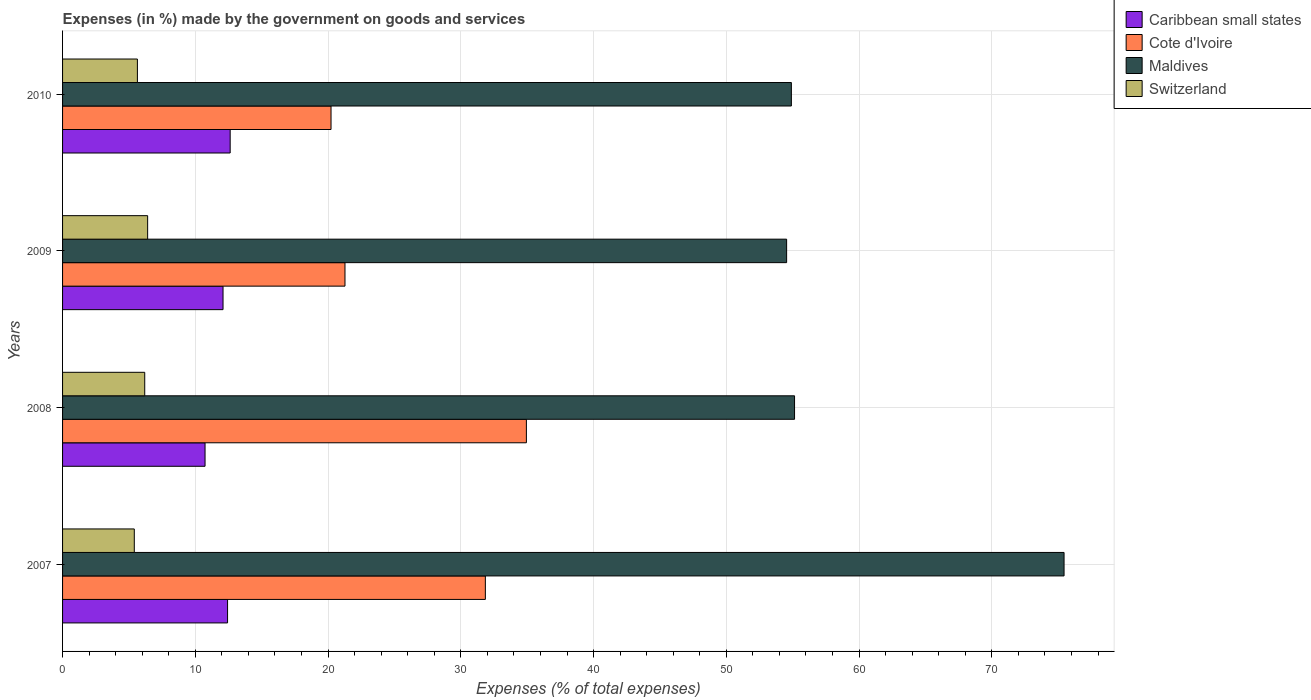How many different coloured bars are there?
Make the answer very short. 4. How many groups of bars are there?
Your answer should be compact. 4. How many bars are there on the 2nd tick from the bottom?
Ensure brevity in your answer.  4. What is the label of the 3rd group of bars from the top?
Give a very brief answer. 2008. In how many cases, is the number of bars for a given year not equal to the number of legend labels?
Your answer should be very brief. 0. What is the percentage of expenses made by the government on goods and services in Maldives in 2010?
Your answer should be very brief. 54.9. Across all years, what is the maximum percentage of expenses made by the government on goods and services in Cote d'Ivoire?
Give a very brief answer. 34.94. Across all years, what is the minimum percentage of expenses made by the government on goods and services in Caribbean small states?
Give a very brief answer. 10.73. In which year was the percentage of expenses made by the government on goods and services in Maldives minimum?
Make the answer very short. 2009. What is the total percentage of expenses made by the government on goods and services in Maldives in the graph?
Make the answer very short. 240.02. What is the difference between the percentage of expenses made by the government on goods and services in Maldives in 2008 and that in 2010?
Keep it short and to the point. 0.24. What is the difference between the percentage of expenses made by the government on goods and services in Cote d'Ivoire in 2009 and the percentage of expenses made by the government on goods and services in Caribbean small states in 2007?
Provide a short and direct response. 8.85. What is the average percentage of expenses made by the government on goods and services in Cote d'Ivoire per year?
Your answer should be very brief. 27.07. In the year 2009, what is the difference between the percentage of expenses made by the government on goods and services in Switzerland and percentage of expenses made by the government on goods and services in Caribbean small states?
Ensure brevity in your answer.  -5.68. In how many years, is the percentage of expenses made by the government on goods and services in Maldives greater than 8 %?
Offer a very short reply. 4. What is the ratio of the percentage of expenses made by the government on goods and services in Maldives in 2007 to that in 2009?
Provide a short and direct response. 1.38. Is the percentage of expenses made by the government on goods and services in Switzerland in 2009 less than that in 2010?
Your response must be concise. No. What is the difference between the highest and the second highest percentage of expenses made by the government on goods and services in Caribbean small states?
Keep it short and to the point. 0.2. What is the difference between the highest and the lowest percentage of expenses made by the government on goods and services in Switzerland?
Provide a short and direct response. 1. In how many years, is the percentage of expenses made by the government on goods and services in Cote d'Ivoire greater than the average percentage of expenses made by the government on goods and services in Cote d'Ivoire taken over all years?
Ensure brevity in your answer.  2. Is the sum of the percentage of expenses made by the government on goods and services in Switzerland in 2007 and 2008 greater than the maximum percentage of expenses made by the government on goods and services in Cote d'Ivoire across all years?
Ensure brevity in your answer.  No. What does the 4th bar from the top in 2010 represents?
Ensure brevity in your answer.  Caribbean small states. What does the 4th bar from the bottom in 2009 represents?
Ensure brevity in your answer.  Switzerland. Is it the case that in every year, the sum of the percentage of expenses made by the government on goods and services in Maldives and percentage of expenses made by the government on goods and services in Switzerland is greater than the percentage of expenses made by the government on goods and services in Caribbean small states?
Provide a succinct answer. Yes. How many bars are there?
Give a very brief answer. 16. Are all the bars in the graph horizontal?
Your answer should be very brief. Yes. Does the graph contain grids?
Offer a terse response. Yes. Where does the legend appear in the graph?
Your answer should be compact. Top right. How many legend labels are there?
Ensure brevity in your answer.  4. How are the legend labels stacked?
Offer a terse response. Vertical. What is the title of the graph?
Your response must be concise. Expenses (in %) made by the government on goods and services. What is the label or title of the X-axis?
Your answer should be compact. Expenses (% of total expenses). What is the Expenses (% of total expenses) of Caribbean small states in 2007?
Your answer should be compact. 12.43. What is the Expenses (% of total expenses) of Cote d'Ivoire in 2007?
Your answer should be very brief. 31.85. What is the Expenses (% of total expenses) of Maldives in 2007?
Your answer should be compact. 75.44. What is the Expenses (% of total expenses) in Switzerland in 2007?
Keep it short and to the point. 5.4. What is the Expenses (% of total expenses) in Caribbean small states in 2008?
Make the answer very short. 10.73. What is the Expenses (% of total expenses) of Cote d'Ivoire in 2008?
Your answer should be very brief. 34.94. What is the Expenses (% of total expenses) in Maldives in 2008?
Offer a terse response. 55.14. What is the Expenses (% of total expenses) of Switzerland in 2008?
Your response must be concise. 6.19. What is the Expenses (% of total expenses) in Caribbean small states in 2009?
Provide a succinct answer. 12.09. What is the Expenses (% of total expenses) of Cote d'Ivoire in 2009?
Make the answer very short. 21.27. What is the Expenses (% of total expenses) of Maldives in 2009?
Provide a short and direct response. 54.54. What is the Expenses (% of total expenses) in Switzerland in 2009?
Your response must be concise. 6.41. What is the Expenses (% of total expenses) of Caribbean small states in 2010?
Ensure brevity in your answer.  12.63. What is the Expenses (% of total expenses) of Cote d'Ivoire in 2010?
Offer a terse response. 20.22. What is the Expenses (% of total expenses) of Maldives in 2010?
Give a very brief answer. 54.9. What is the Expenses (% of total expenses) in Switzerland in 2010?
Make the answer very short. 5.64. Across all years, what is the maximum Expenses (% of total expenses) of Caribbean small states?
Make the answer very short. 12.63. Across all years, what is the maximum Expenses (% of total expenses) of Cote d'Ivoire?
Keep it short and to the point. 34.94. Across all years, what is the maximum Expenses (% of total expenses) of Maldives?
Your response must be concise. 75.44. Across all years, what is the maximum Expenses (% of total expenses) of Switzerland?
Keep it short and to the point. 6.41. Across all years, what is the minimum Expenses (% of total expenses) of Caribbean small states?
Offer a terse response. 10.73. Across all years, what is the minimum Expenses (% of total expenses) in Cote d'Ivoire?
Ensure brevity in your answer.  20.22. Across all years, what is the minimum Expenses (% of total expenses) in Maldives?
Your response must be concise. 54.54. Across all years, what is the minimum Expenses (% of total expenses) in Switzerland?
Ensure brevity in your answer.  5.4. What is the total Expenses (% of total expenses) in Caribbean small states in the graph?
Provide a succinct answer. 47.88. What is the total Expenses (% of total expenses) in Cote d'Ivoire in the graph?
Your answer should be very brief. 108.28. What is the total Expenses (% of total expenses) in Maldives in the graph?
Your answer should be compact. 240.02. What is the total Expenses (% of total expenses) of Switzerland in the graph?
Offer a very short reply. 23.64. What is the difference between the Expenses (% of total expenses) of Caribbean small states in 2007 and that in 2008?
Keep it short and to the point. 1.7. What is the difference between the Expenses (% of total expenses) in Cote d'Ivoire in 2007 and that in 2008?
Provide a short and direct response. -3.09. What is the difference between the Expenses (% of total expenses) in Maldives in 2007 and that in 2008?
Your answer should be very brief. 20.3. What is the difference between the Expenses (% of total expenses) of Switzerland in 2007 and that in 2008?
Provide a short and direct response. -0.79. What is the difference between the Expenses (% of total expenses) in Caribbean small states in 2007 and that in 2009?
Make the answer very short. 0.34. What is the difference between the Expenses (% of total expenses) in Cote d'Ivoire in 2007 and that in 2009?
Keep it short and to the point. 10.57. What is the difference between the Expenses (% of total expenses) in Maldives in 2007 and that in 2009?
Offer a terse response. 20.9. What is the difference between the Expenses (% of total expenses) in Switzerland in 2007 and that in 2009?
Your answer should be compact. -1. What is the difference between the Expenses (% of total expenses) in Caribbean small states in 2007 and that in 2010?
Provide a short and direct response. -0.2. What is the difference between the Expenses (% of total expenses) of Cote d'Ivoire in 2007 and that in 2010?
Provide a short and direct response. 11.63. What is the difference between the Expenses (% of total expenses) of Maldives in 2007 and that in 2010?
Your response must be concise. 20.54. What is the difference between the Expenses (% of total expenses) of Switzerland in 2007 and that in 2010?
Give a very brief answer. -0.23. What is the difference between the Expenses (% of total expenses) of Caribbean small states in 2008 and that in 2009?
Offer a terse response. -1.35. What is the difference between the Expenses (% of total expenses) in Cote d'Ivoire in 2008 and that in 2009?
Offer a terse response. 13.66. What is the difference between the Expenses (% of total expenses) in Maldives in 2008 and that in 2009?
Provide a succinct answer. 0.6. What is the difference between the Expenses (% of total expenses) of Switzerland in 2008 and that in 2009?
Give a very brief answer. -0.22. What is the difference between the Expenses (% of total expenses) in Caribbean small states in 2008 and that in 2010?
Your answer should be compact. -1.89. What is the difference between the Expenses (% of total expenses) of Cote d'Ivoire in 2008 and that in 2010?
Keep it short and to the point. 14.72. What is the difference between the Expenses (% of total expenses) of Maldives in 2008 and that in 2010?
Keep it short and to the point. 0.24. What is the difference between the Expenses (% of total expenses) in Switzerland in 2008 and that in 2010?
Give a very brief answer. 0.55. What is the difference between the Expenses (% of total expenses) in Caribbean small states in 2009 and that in 2010?
Give a very brief answer. -0.54. What is the difference between the Expenses (% of total expenses) of Cote d'Ivoire in 2009 and that in 2010?
Provide a succinct answer. 1.05. What is the difference between the Expenses (% of total expenses) of Maldives in 2009 and that in 2010?
Offer a terse response. -0.36. What is the difference between the Expenses (% of total expenses) in Switzerland in 2009 and that in 2010?
Ensure brevity in your answer.  0.77. What is the difference between the Expenses (% of total expenses) of Caribbean small states in 2007 and the Expenses (% of total expenses) of Cote d'Ivoire in 2008?
Make the answer very short. -22.51. What is the difference between the Expenses (% of total expenses) in Caribbean small states in 2007 and the Expenses (% of total expenses) in Maldives in 2008?
Offer a very short reply. -42.71. What is the difference between the Expenses (% of total expenses) in Caribbean small states in 2007 and the Expenses (% of total expenses) in Switzerland in 2008?
Your answer should be very brief. 6.24. What is the difference between the Expenses (% of total expenses) of Cote d'Ivoire in 2007 and the Expenses (% of total expenses) of Maldives in 2008?
Keep it short and to the point. -23.29. What is the difference between the Expenses (% of total expenses) in Cote d'Ivoire in 2007 and the Expenses (% of total expenses) in Switzerland in 2008?
Your response must be concise. 25.66. What is the difference between the Expenses (% of total expenses) in Maldives in 2007 and the Expenses (% of total expenses) in Switzerland in 2008?
Keep it short and to the point. 69.25. What is the difference between the Expenses (% of total expenses) of Caribbean small states in 2007 and the Expenses (% of total expenses) of Cote d'Ivoire in 2009?
Offer a very short reply. -8.85. What is the difference between the Expenses (% of total expenses) in Caribbean small states in 2007 and the Expenses (% of total expenses) in Maldives in 2009?
Make the answer very short. -42.11. What is the difference between the Expenses (% of total expenses) of Caribbean small states in 2007 and the Expenses (% of total expenses) of Switzerland in 2009?
Provide a succinct answer. 6.02. What is the difference between the Expenses (% of total expenses) of Cote d'Ivoire in 2007 and the Expenses (% of total expenses) of Maldives in 2009?
Provide a short and direct response. -22.69. What is the difference between the Expenses (% of total expenses) of Cote d'Ivoire in 2007 and the Expenses (% of total expenses) of Switzerland in 2009?
Make the answer very short. 25.44. What is the difference between the Expenses (% of total expenses) in Maldives in 2007 and the Expenses (% of total expenses) in Switzerland in 2009?
Keep it short and to the point. 69.03. What is the difference between the Expenses (% of total expenses) of Caribbean small states in 2007 and the Expenses (% of total expenses) of Cote d'Ivoire in 2010?
Offer a terse response. -7.79. What is the difference between the Expenses (% of total expenses) of Caribbean small states in 2007 and the Expenses (% of total expenses) of Maldives in 2010?
Provide a short and direct response. -42.47. What is the difference between the Expenses (% of total expenses) of Caribbean small states in 2007 and the Expenses (% of total expenses) of Switzerland in 2010?
Offer a very short reply. 6.79. What is the difference between the Expenses (% of total expenses) in Cote d'Ivoire in 2007 and the Expenses (% of total expenses) in Maldives in 2010?
Your answer should be compact. -23.05. What is the difference between the Expenses (% of total expenses) in Cote d'Ivoire in 2007 and the Expenses (% of total expenses) in Switzerland in 2010?
Make the answer very short. 26.21. What is the difference between the Expenses (% of total expenses) in Maldives in 2007 and the Expenses (% of total expenses) in Switzerland in 2010?
Provide a short and direct response. 69.8. What is the difference between the Expenses (% of total expenses) of Caribbean small states in 2008 and the Expenses (% of total expenses) of Cote d'Ivoire in 2009?
Provide a short and direct response. -10.54. What is the difference between the Expenses (% of total expenses) in Caribbean small states in 2008 and the Expenses (% of total expenses) in Maldives in 2009?
Your response must be concise. -43.81. What is the difference between the Expenses (% of total expenses) in Caribbean small states in 2008 and the Expenses (% of total expenses) in Switzerland in 2009?
Offer a very short reply. 4.32. What is the difference between the Expenses (% of total expenses) of Cote d'Ivoire in 2008 and the Expenses (% of total expenses) of Maldives in 2009?
Provide a succinct answer. -19.6. What is the difference between the Expenses (% of total expenses) in Cote d'Ivoire in 2008 and the Expenses (% of total expenses) in Switzerland in 2009?
Your answer should be compact. 28.53. What is the difference between the Expenses (% of total expenses) in Maldives in 2008 and the Expenses (% of total expenses) in Switzerland in 2009?
Give a very brief answer. 48.73. What is the difference between the Expenses (% of total expenses) of Caribbean small states in 2008 and the Expenses (% of total expenses) of Cote d'Ivoire in 2010?
Make the answer very short. -9.49. What is the difference between the Expenses (% of total expenses) of Caribbean small states in 2008 and the Expenses (% of total expenses) of Maldives in 2010?
Make the answer very short. -44.17. What is the difference between the Expenses (% of total expenses) of Caribbean small states in 2008 and the Expenses (% of total expenses) of Switzerland in 2010?
Provide a short and direct response. 5.1. What is the difference between the Expenses (% of total expenses) in Cote d'Ivoire in 2008 and the Expenses (% of total expenses) in Maldives in 2010?
Ensure brevity in your answer.  -19.96. What is the difference between the Expenses (% of total expenses) in Cote d'Ivoire in 2008 and the Expenses (% of total expenses) in Switzerland in 2010?
Offer a terse response. 29.3. What is the difference between the Expenses (% of total expenses) of Maldives in 2008 and the Expenses (% of total expenses) of Switzerland in 2010?
Your answer should be compact. 49.5. What is the difference between the Expenses (% of total expenses) in Caribbean small states in 2009 and the Expenses (% of total expenses) in Cote d'Ivoire in 2010?
Make the answer very short. -8.13. What is the difference between the Expenses (% of total expenses) in Caribbean small states in 2009 and the Expenses (% of total expenses) in Maldives in 2010?
Your response must be concise. -42.81. What is the difference between the Expenses (% of total expenses) of Caribbean small states in 2009 and the Expenses (% of total expenses) of Switzerland in 2010?
Provide a short and direct response. 6.45. What is the difference between the Expenses (% of total expenses) of Cote d'Ivoire in 2009 and the Expenses (% of total expenses) of Maldives in 2010?
Make the answer very short. -33.63. What is the difference between the Expenses (% of total expenses) in Cote d'Ivoire in 2009 and the Expenses (% of total expenses) in Switzerland in 2010?
Your response must be concise. 15.64. What is the difference between the Expenses (% of total expenses) of Maldives in 2009 and the Expenses (% of total expenses) of Switzerland in 2010?
Provide a short and direct response. 48.9. What is the average Expenses (% of total expenses) of Caribbean small states per year?
Provide a succinct answer. 11.97. What is the average Expenses (% of total expenses) of Cote d'Ivoire per year?
Your answer should be very brief. 27.07. What is the average Expenses (% of total expenses) in Maldives per year?
Provide a succinct answer. 60.01. What is the average Expenses (% of total expenses) of Switzerland per year?
Make the answer very short. 5.91. In the year 2007, what is the difference between the Expenses (% of total expenses) of Caribbean small states and Expenses (% of total expenses) of Cote d'Ivoire?
Give a very brief answer. -19.42. In the year 2007, what is the difference between the Expenses (% of total expenses) of Caribbean small states and Expenses (% of total expenses) of Maldives?
Your response must be concise. -63.01. In the year 2007, what is the difference between the Expenses (% of total expenses) of Caribbean small states and Expenses (% of total expenses) of Switzerland?
Provide a succinct answer. 7.03. In the year 2007, what is the difference between the Expenses (% of total expenses) in Cote d'Ivoire and Expenses (% of total expenses) in Maldives?
Your response must be concise. -43.59. In the year 2007, what is the difference between the Expenses (% of total expenses) of Cote d'Ivoire and Expenses (% of total expenses) of Switzerland?
Ensure brevity in your answer.  26.44. In the year 2007, what is the difference between the Expenses (% of total expenses) of Maldives and Expenses (% of total expenses) of Switzerland?
Offer a very short reply. 70.04. In the year 2008, what is the difference between the Expenses (% of total expenses) of Caribbean small states and Expenses (% of total expenses) of Cote d'Ivoire?
Keep it short and to the point. -24.21. In the year 2008, what is the difference between the Expenses (% of total expenses) of Caribbean small states and Expenses (% of total expenses) of Maldives?
Ensure brevity in your answer.  -44.41. In the year 2008, what is the difference between the Expenses (% of total expenses) of Caribbean small states and Expenses (% of total expenses) of Switzerland?
Make the answer very short. 4.54. In the year 2008, what is the difference between the Expenses (% of total expenses) in Cote d'Ivoire and Expenses (% of total expenses) in Maldives?
Provide a succinct answer. -20.2. In the year 2008, what is the difference between the Expenses (% of total expenses) in Cote d'Ivoire and Expenses (% of total expenses) in Switzerland?
Provide a succinct answer. 28.75. In the year 2008, what is the difference between the Expenses (% of total expenses) in Maldives and Expenses (% of total expenses) in Switzerland?
Offer a terse response. 48.95. In the year 2009, what is the difference between the Expenses (% of total expenses) of Caribbean small states and Expenses (% of total expenses) of Cote d'Ivoire?
Your response must be concise. -9.19. In the year 2009, what is the difference between the Expenses (% of total expenses) in Caribbean small states and Expenses (% of total expenses) in Maldives?
Offer a very short reply. -42.45. In the year 2009, what is the difference between the Expenses (% of total expenses) of Caribbean small states and Expenses (% of total expenses) of Switzerland?
Provide a short and direct response. 5.68. In the year 2009, what is the difference between the Expenses (% of total expenses) of Cote d'Ivoire and Expenses (% of total expenses) of Maldives?
Make the answer very short. -33.27. In the year 2009, what is the difference between the Expenses (% of total expenses) of Cote d'Ivoire and Expenses (% of total expenses) of Switzerland?
Make the answer very short. 14.87. In the year 2009, what is the difference between the Expenses (% of total expenses) in Maldives and Expenses (% of total expenses) in Switzerland?
Offer a very short reply. 48.13. In the year 2010, what is the difference between the Expenses (% of total expenses) in Caribbean small states and Expenses (% of total expenses) in Cote d'Ivoire?
Offer a very short reply. -7.6. In the year 2010, what is the difference between the Expenses (% of total expenses) in Caribbean small states and Expenses (% of total expenses) in Maldives?
Offer a terse response. -42.27. In the year 2010, what is the difference between the Expenses (% of total expenses) in Caribbean small states and Expenses (% of total expenses) in Switzerland?
Your response must be concise. 6.99. In the year 2010, what is the difference between the Expenses (% of total expenses) of Cote d'Ivoire and Expenses (% of total expenses) of Maldives?
Provide a succinct answer. -34.68. In the year 2010, what is the difference between the Expenses (% of total expenses) in Cote d'Ivoire and Expenses (% of total expenses) in Switzerland?
Make the answer very short. 14.58. In the year 2010, what is the difference between the Expenses (% of total expenses) in Maldives and Expenses (% of total expenses) in Switzerland?
Give a very brief answer. 49.26. What is the ratio of the Expenses (% of total expenses) of Caribbean small states in 2007 to that in 2008?
Offer a very short reply. 1.16. What is the ratio of the Expenses (% of total expenses) of Cote d'Ivoire in 2007 to that in 2008?
Give a very brief answer. 0.91. What is the ratio of the Expenses (% of total expenses) in Maldives in 2007 to that in 2008?
Provide a short and direct response. 1.37. What is the ratio of the Expenses (% of total expenses) in Switzerland in 2007 to that in 2008?
Make the answer very short. 0.87. What is the ratio of the Expenses (% of total expenses) in Caribbean small states in 2007 to that in 2009?
Your answer should be compact. 1.03. What is the ratio of the Expenses (% of total expenses) of Cote d'Ivoire in 2007 to that in 2009?
Make the answer very short. 1.5. What is the ratio of the Expenses (% of total expenses) in Maldives in 2007 to that in 2009?
Your answer should be compact. 1.38. What is the ratio of the Expenses (% of total expenses) in Switzerland in 2007 to that in 2009?
Your response must be concise. 0.84. What is the ratio of the Expenses (% of total expenses) in Caribbean small states in 2007 to that in 2010?
Give a very brief answer. 0.98. What is the ratio of the Expenses (% of total expenses) in Cote d'Ivoire in 2007 to that in 2010?
Provide a short and direct response. 1.57. What is the ratio of the Expenses (% of total expenses) of Maldives in 2007 to that in 2010?
Offer a terse response. 1.37. What is the ratio of the Expenses (% of total expenses) of Switzerland in 2007 to that in 2010?
Provide a succinct answer. 0.96. What is the ratio of the Expenses (% of total expenses) in Caribbean small states in 2008 to that in 2009?
Your response must be concise. 0.89. What is the ratio of the Expenses (% of total expenses) of Cote d'Ivoire in 2008 to that in 2009?
Your answer should be very brief. 1.64. What is the ratio of the Expenses (% of total expenses) in Maldives in 2008 to that in 2009?
Ensure brevity in your answer.  1.01. What is the ratio of the Expenses (% of total expenses) of Switzerland in 2008 to that in 2009?
Your answer should be compact. 0.97. What is the ratio of the Expenses (% of total expenses) in Caribbean small states in 2008 to that in 2010?
Ensure brevity in your answer.  0.85. What is the ratio of the Expenses (% of total expenses) in Cote d'Ivoire in 2008 to that in 2010?
Your answer should be very brief. 1.73. What is the ratio of the Expenses (% of total expenses) of Switzerland in 2008 to that in 2010?
Give a very brief answer. 1.1. What is the ratio of the Expenses (% of total expenses) in Caribbean small states in 2009 to that in 2010?
Give a very brief answer. 0.96. What is the ratio of the Expenses (% of total expenses) of Cote d'Ivoire in 2009 to that in 2010?
Your answer should be very brief. 1.05. What is the ratio of the Expenses (% of total expenses) in Switzerland in 2009 to that in 2010?
Provide a succinct answer. 1.14. What is the difference between the highest and the second highest Expenses (% of total expenses) of Caribbean small states?
Your answer should be compact. 0.2. What is the difference between the highest and the second highest Expenses (% of total expenses) in Cote d'Ivoire?
Your answer should be compact. 3.09. What is the difference between the highest and the second highest Expenses (% of total expenses) of Maldives?
Offer a terse response. 20.3. What is the difference between the highest and the second highest Expenses (% of total expenses) of Switzerland?
Your answer should be very brief. 0.22. What is the difference between the highest and the lowest Expenses (% of total expenses) in Caribbean small states?
Provide a short and direct response. 1.89. What is the difference between the highest and the lowest Expenses (% of total expenses) in Cote d'Ivoire?
Keep it short and to the point. 14.72. What is the difference between the highest and the lowest Expenses (% of total expenses) of Maldives?
Your response must be concise. 20.9. What is the difference between the highest and the lowest Expenses (% of total expenses) of Switzerland?
Provide a short and direct response. 1. 